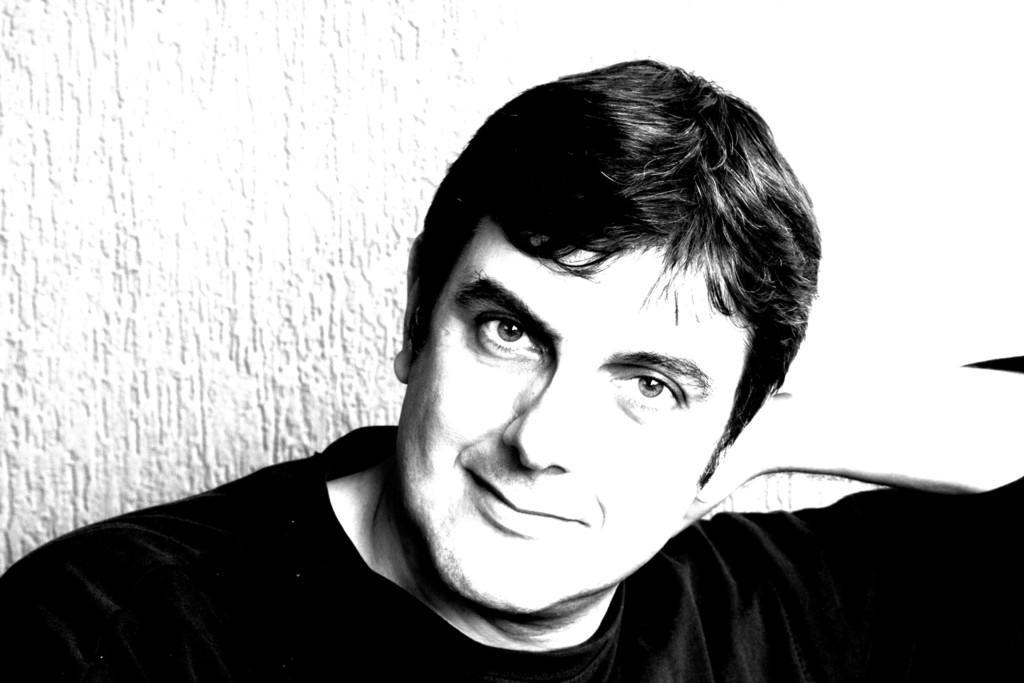How would you summarize this image in a sentence or two? In this image we can see the black and white image of a man. 